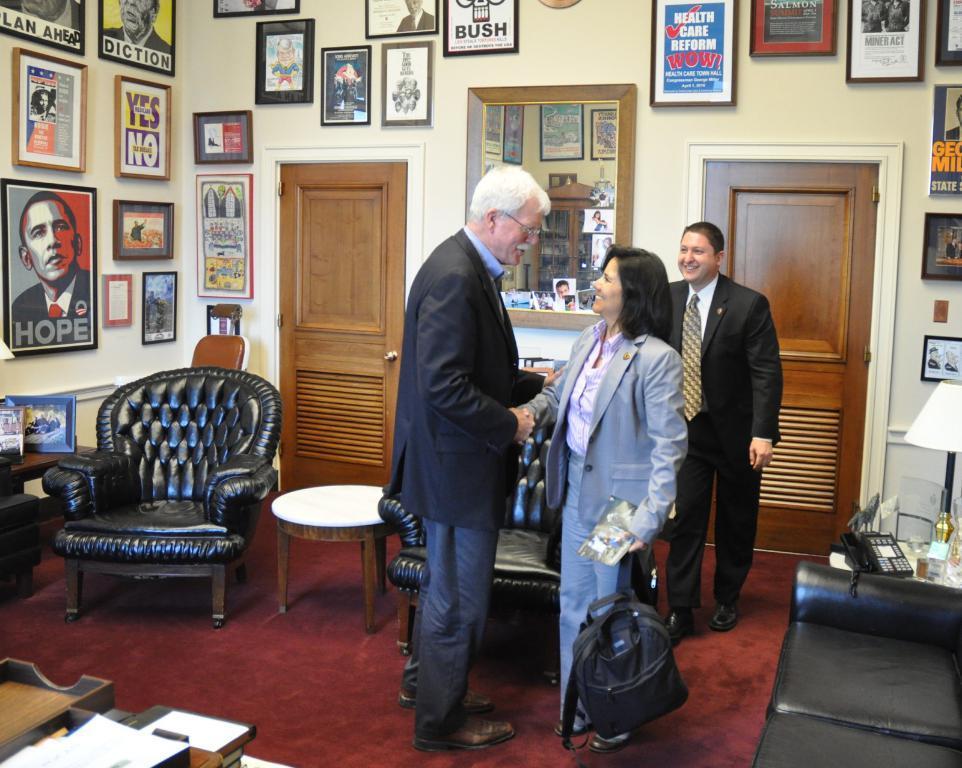In one or two sentences, can you explain what this image depicts? There is a person standing and wishing to the other woman as she is holding the backpack in her hand and shaking their hands together and the other person standing at the back of the lady woman and smiling seeing and smiling to those persons. There are two doors in the background and a mirror hanging over in the background in the picture. There are some posters and wall picture frames on the wall in the left side of the picture. There is a chair and centre table on the floor, the centre table is white in color and chair is black in color. There is a sofa in the right corner of the picture and beside the sofa there is a corner table holding a telephone and a lamp holder and there are some books in the left corner of the picture. 